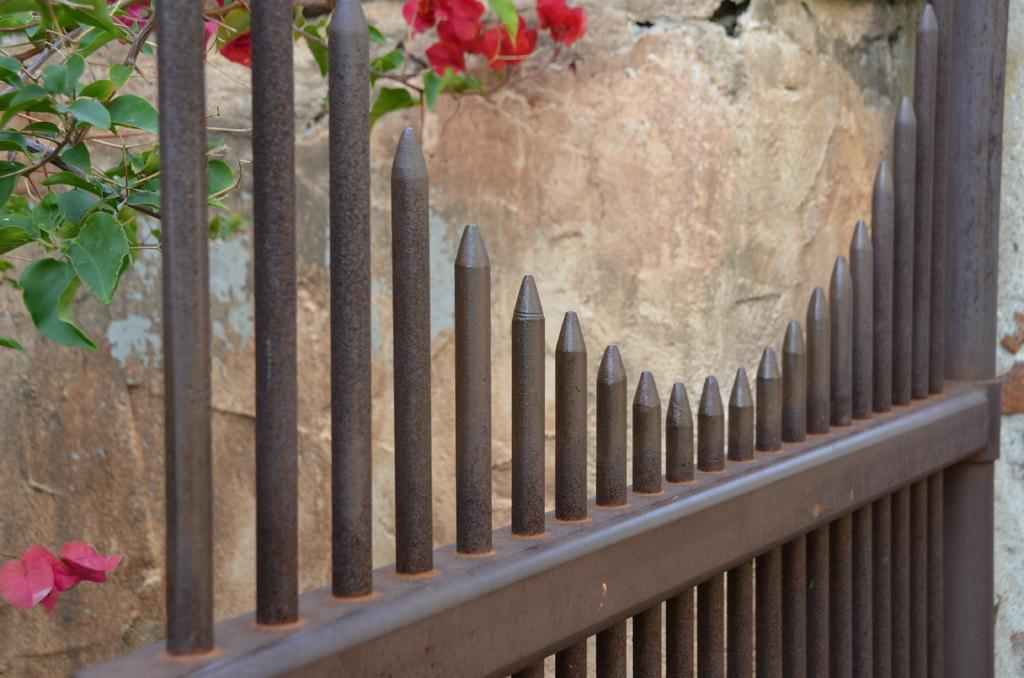What type of barrier is present in the image? There is a metal railing in the image. What can be seen behind the metal railing? There are rocks behind the railing. Are there any plants visible in the image? Yes, leaves and flowers of a plant are visible in the top left of the image. What type of glove is the minister wearing in the image? There is no minister or glove present in the image. 